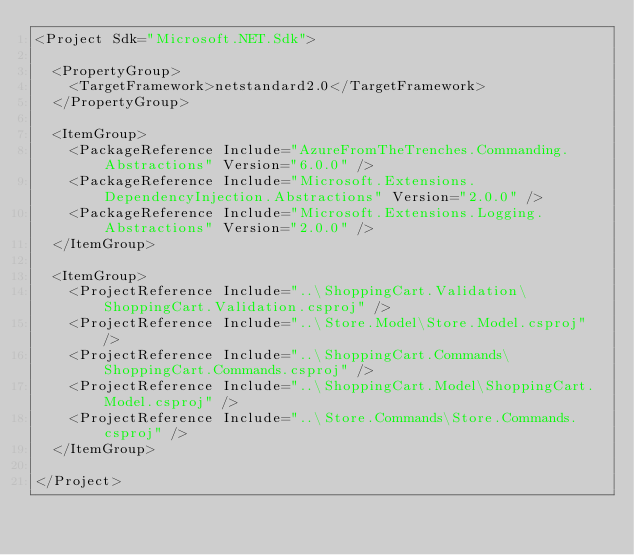<code> <loc_0><loc_0><loc_500><loc_500><_XML_><Project Sdk="Microsoft.NET.Sdk">

  <PropertyGroup>
    <TargetFramework>netstandard2.0</TargetFramework>
  </PropertyGroup>

  <ItemGroup>
    <PackageReference Include="AzureFromTheTrenches.Commanding.Abstractions" Version="6.0.0" />
    <PackageReference Include="Microsoft.Extensions.DependencyInjection.Abstractions" Version="2.0.0" />
    <PackageReference Include="Microsoft.Extensions.Logging.Abstractions" Version="2.0.0" />
  </ItemGroup>

  <ItemGroup>
    <ProjectReference Include="..\ShoppingCart.Validation\ShoppingCart.Validation.csproj" />
    <ProjectReference Include="..\Store.Model\Store.Model.csproj" />
    <ProjectReference Include="..\ShoppingCart.Commands\ShoppingCart.Commands.csproj" />
    <ProjectReference Include="..\ShoppingCart.Model\ShoppingCart.Model.csproj" />
    <ProjectReference Include="..\Store.Commands\Store.Commands.csproj" />
  </ItemGroup>

</Project>
</code> 